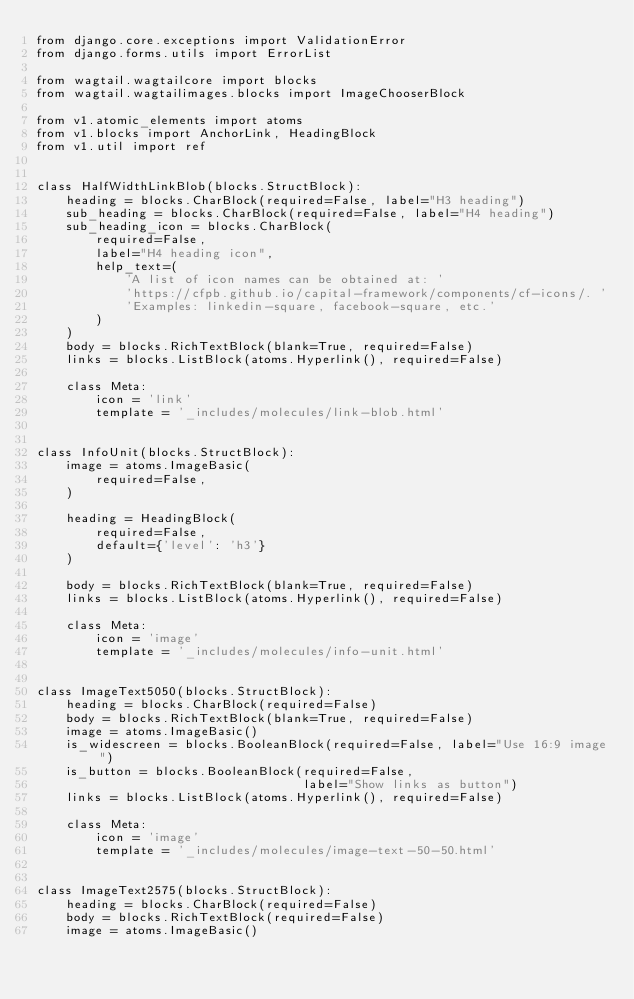<code> <loc_0><loc_0><loc_500><loc_500><_Python_>from django.core.exceptions import ValidationError
from django.forms.utils import ErrorList

from wagtail.wagtailcore import blocks
from wagtail.wagtailimages.blocks import ImageChooserBlock

from v1.atomic_elements import atoms
from v1.blocks import AnchorLink, HeadingBlock
from v1.util import ref


class HalfWidthLinkBlob(blocks.StructBlock):
    heading = blocks.CharBlock(required=False, label="H3 heading")
    sub_heading = blocks.CharBlock(required=False, label="H4 heading")
    sub_heading_icon = blocks.CharBlock(
        required=False,
        label="H4 heading icon",
        help_text=(
            'A list of icon names can be obtained at: '
            'https://cfpb.github.io/capital-framework/components/cf-icons/. '
            'Examples: linkedin-square, facebook-square, etc.'
        )
    )
    body = blocks.RichTextBlock(blank=True, required=False)
    links = blocks.ListBlock(atoms.Hyperlink(), required=False)

    class Meta:
        icon = 'link'
        template = '_includes/molecules/link-blob.html'


class InfoUnit(blocks.StructBlock):
    image = atoms.ImageBasic(
        required=False,
    )

    heading = HeadingBlock(
        required=False,
        default={'level': 'h3'}
    )

    body = blocks.RichTextBlock(blank=True, required=False)
    links = blocks.ListBlock(atoms.Hyperlink(), required=False)

    class Meta:
        icon = 'image'
        template = '_includes/molecules/info-unit.html'


class ImageText5050(blocks.StructBlock):
    heading = blocks.CharBlock(required=False)
    body = blocks.RichTextBlock(blank=True, required=False)
    image = atoms.ImageBasic()
    is_widescreen = blocks.BooleanBlock(required=False, label="Use 16:9 image")
    is_button = blocks.BooleanBlock(required=False,
                                    label="Show links as button")
    links = blocks.ListBlock(atoms.Hyperlink(), required=False)

    class Meta:
        icon = 'image'
        template = '_includes/molecules/image-text-50-50.html'


class ImageText2575(blocks.StructBlock):
    heading = blocks.CharBlock(required=False)
    body = blocks.RichTextBlock(required=False)
    image = atoms.ImageBasic()</code> 